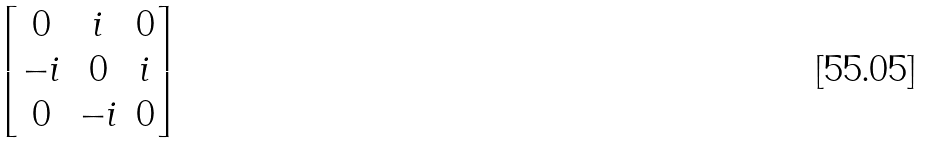<formula> <loc_0><loc_0><loc_500><loc_500>\begin{bmatrix} 0 & i & 0 \\ - i & 0 & i \\ 0 & - i & 0 \end{bmatrix}</formula> 